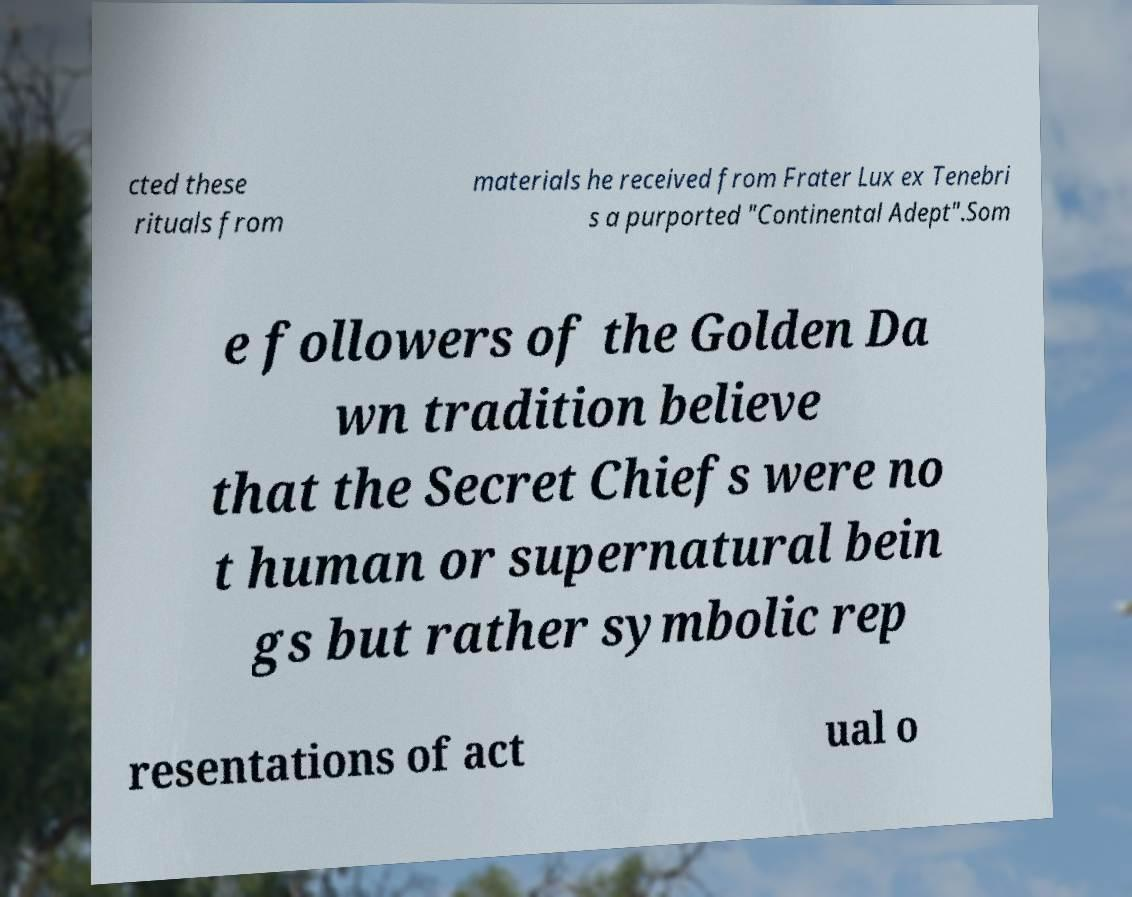Can you accurately transcribe the text from the provided image for me? cted these rituals from materials he received from Frater Lux ex Tenebri s a purported "Continental Adept".Som e followers of the Golden Da wn tradition believe that the Secret Chiefs were no t human or supernatural bein gs but rather symbolic rep resentations of act ual o 